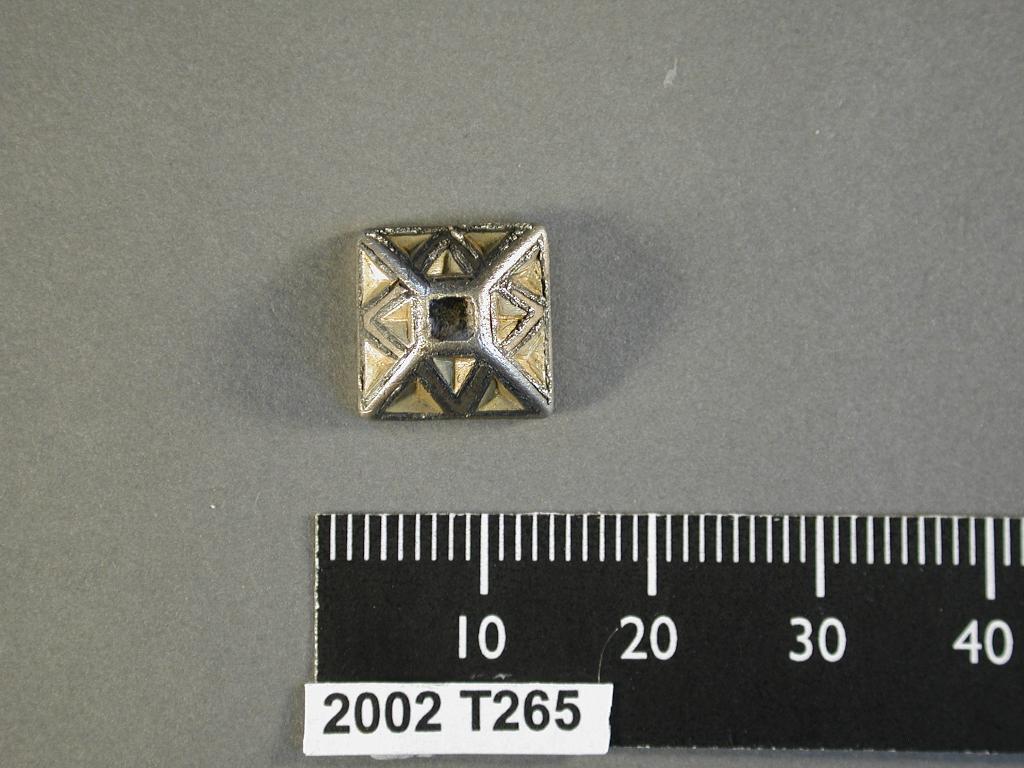What year was the it manufactured in?
Give a very brief answer. 2002. 